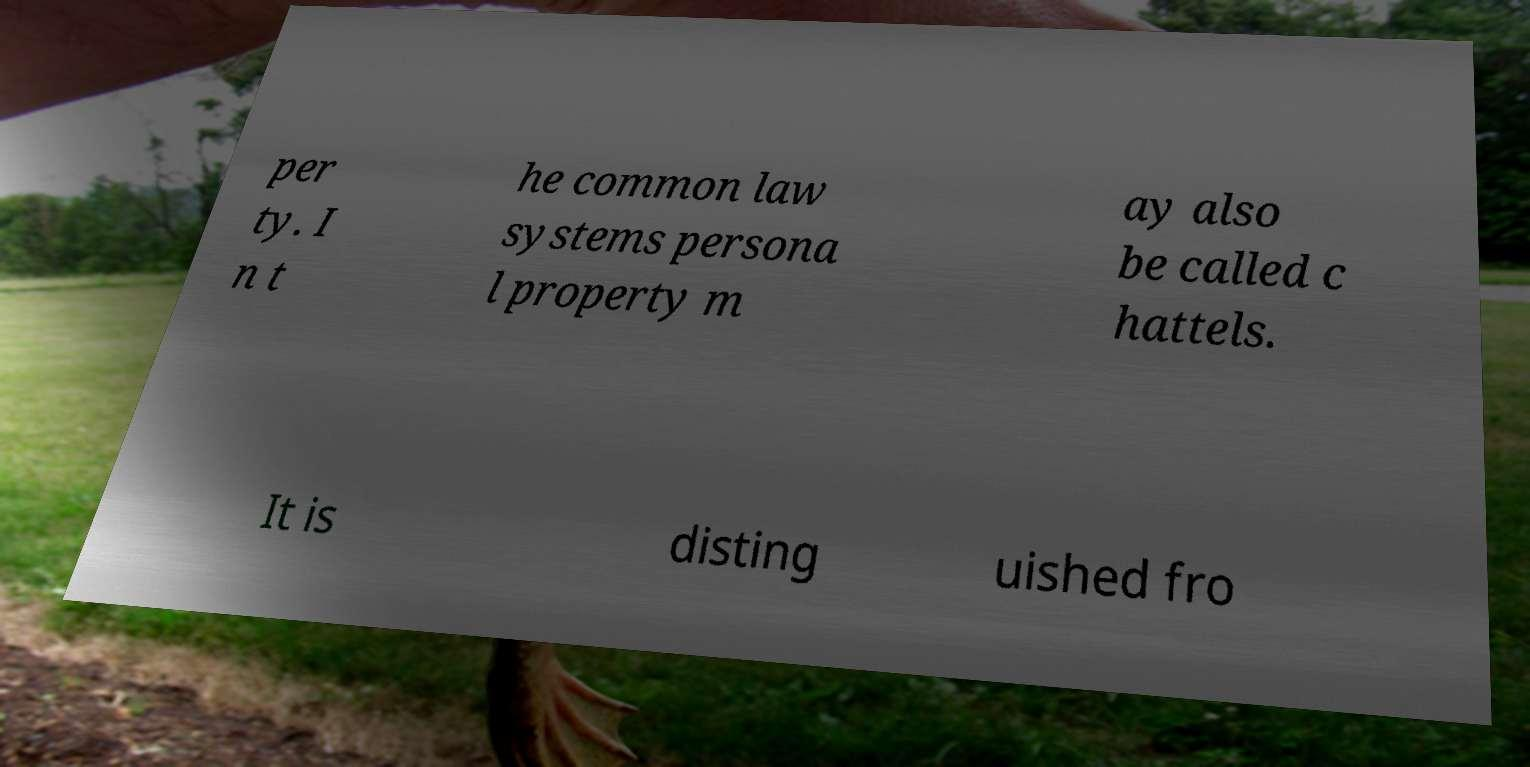What messages or text are displayed in this image? I need them in a readable, typed format. per ty. I n t he common law systems persona l property m ay also be called c hattels. It is disting uished fro 